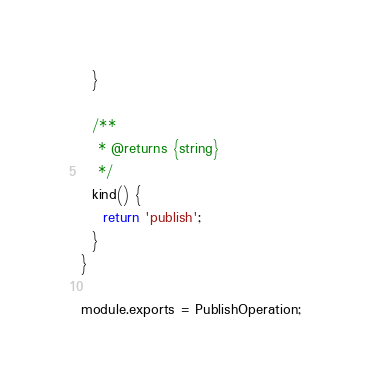<code> <loc_0><loc_0><loc_500><loc_500><_JavaScript_>  }

  /**
   * @returns {string}
   */
  kind() {
    return 'publish';
  }
}

module.exports = PublishOperation;
</code> 